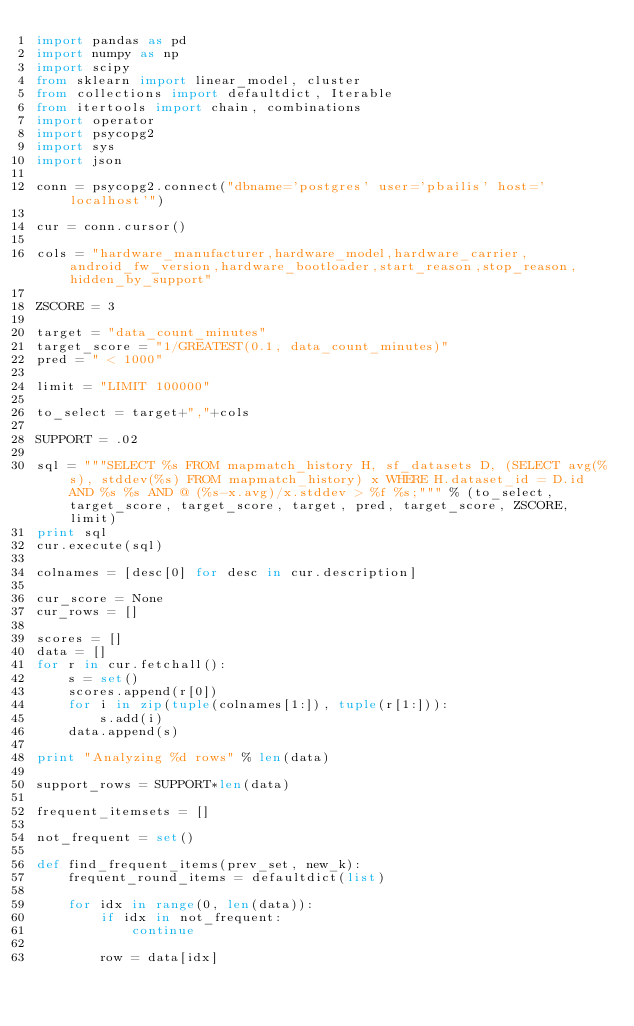Convert code to text. <code><loc_0><loc_0><loc_500><loc_500><_Python_>import pandas as pd
import numpy as np
import scipy
from sklearn import linear_model, cluster
from collections import defaultdict, Iterable
from itertools import chain, combinations
import operator
import psycopg2
import sys
import json

conn = psycopg2.connect("dbname='postgres' user='pbailis' host='localhost'")

cur = conn.cursor()

cols = "hardware_manufacturer,hardware_model,hardware_carrier,android_fw_version,hardware_bootloader,start_reason,stop_reason,hidden_by_support"

ZSCORE = 3

target = "data_count_minutes"
target_score = "1/GREATEST(0.1, data_count_minutes)"
pred = " < 1000"

limit = "LIMIT 100000"

to_select = target+","+cols

SUPPORT = .02

sql = """SELECT %s FROM mapmatch_history H, sf_datasets D, (SELECT avg(%s), stddev(%s) FROM mapmatch_history) x WHERE H.dataset_id = D.id AND %s %s AND @ (%s-x.avg)/x.stddev > %f %s;""" % (to_select, target_score, target_score, target, pred, target_score, ZSCORE, limit)
print sql
cur.execute(sql)

colnames = [desc[0] for desc in cur.description]

cur_score = None
cur_rows = []

scores = []
data = []
for r in cur.fetchall():
    s = set()
    scores.append(r[0])
    for i in zip(tuple(colnames[1:]), tuple(r[1:])):
        s.add(i)
    data.append(s)

print "Analyzing %d rows" % len(data)

support_rows = SUPPORT*len(data)

frequent_itemsets = []

not_frequent = set()

def find_frequent_items(prev_set, new_k):
    frequent_round_items = defaultdict(list)
     
    for idx in range(0, len(data)):
        if idx in not_frequent:
            continue
        
        row = data[idx]</code> 